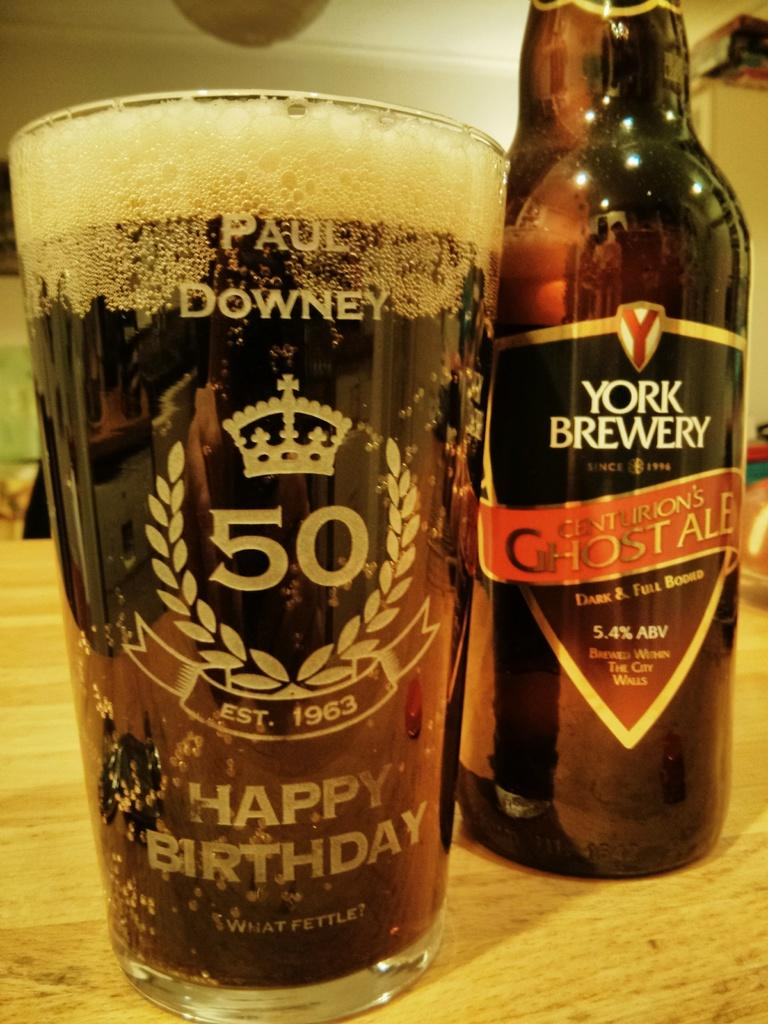<image>
Render a clear and concise summary of the photo. a bottle of york brewery centurion's ghost ale 